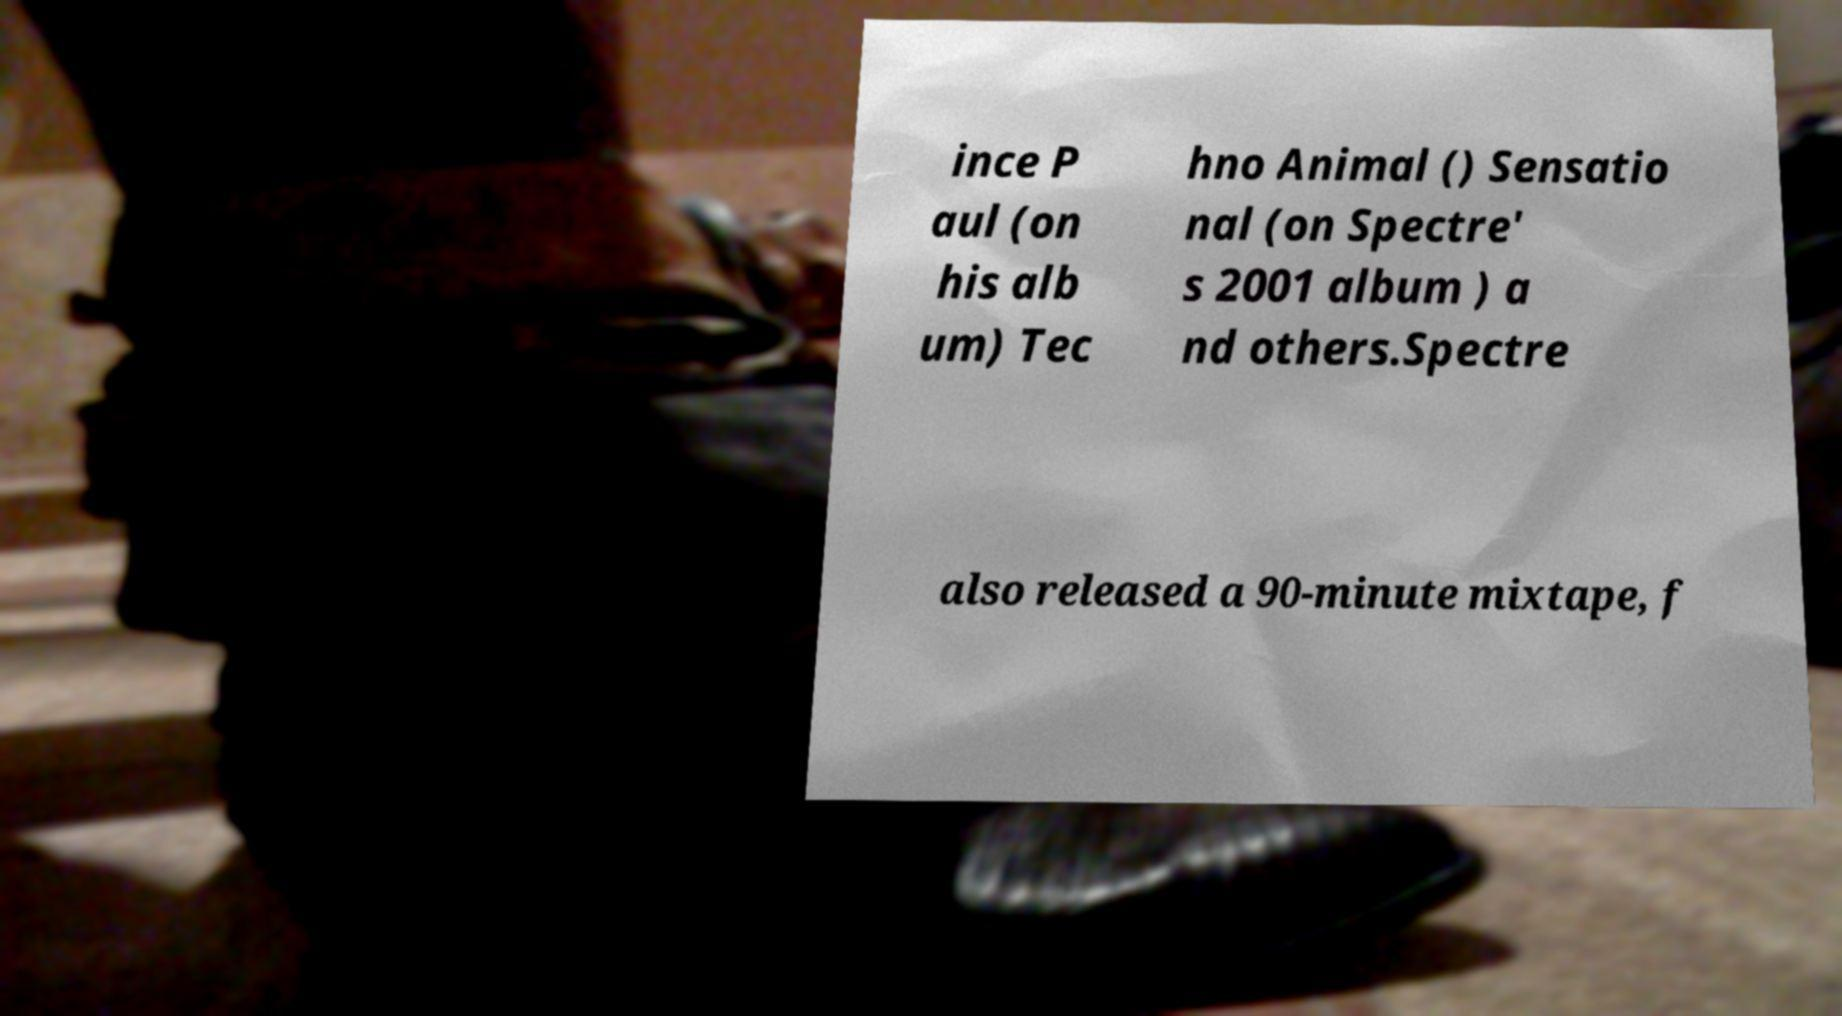I need the written content from this picture converted into text. Can you do that? ince P aul (on his alb um) Tec hno Animal () Sensatio nal (on Spectre' s 2001 album ) a nd others.Spectre also released a 90-minute mixtape, f 